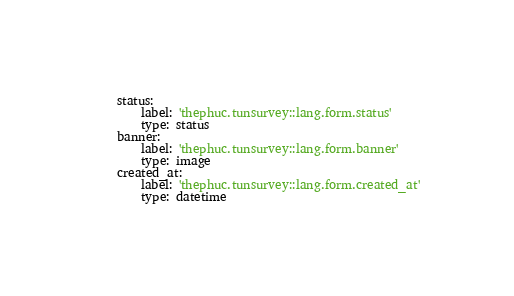Convert code to text. <code><loc_0><loc_0><loc_500><loc_500><_YAML_>    status:
        label: 'thephuc.tunsurvey::lang.form.status'
        type: status
    banner:
        label: 'thephuc.tunsurvey::lang.form.banner'
        type: image
    created_at:
        label: 'thephuc.tunsurvey::lang.form.created_at'
        type: datetime
</code> 